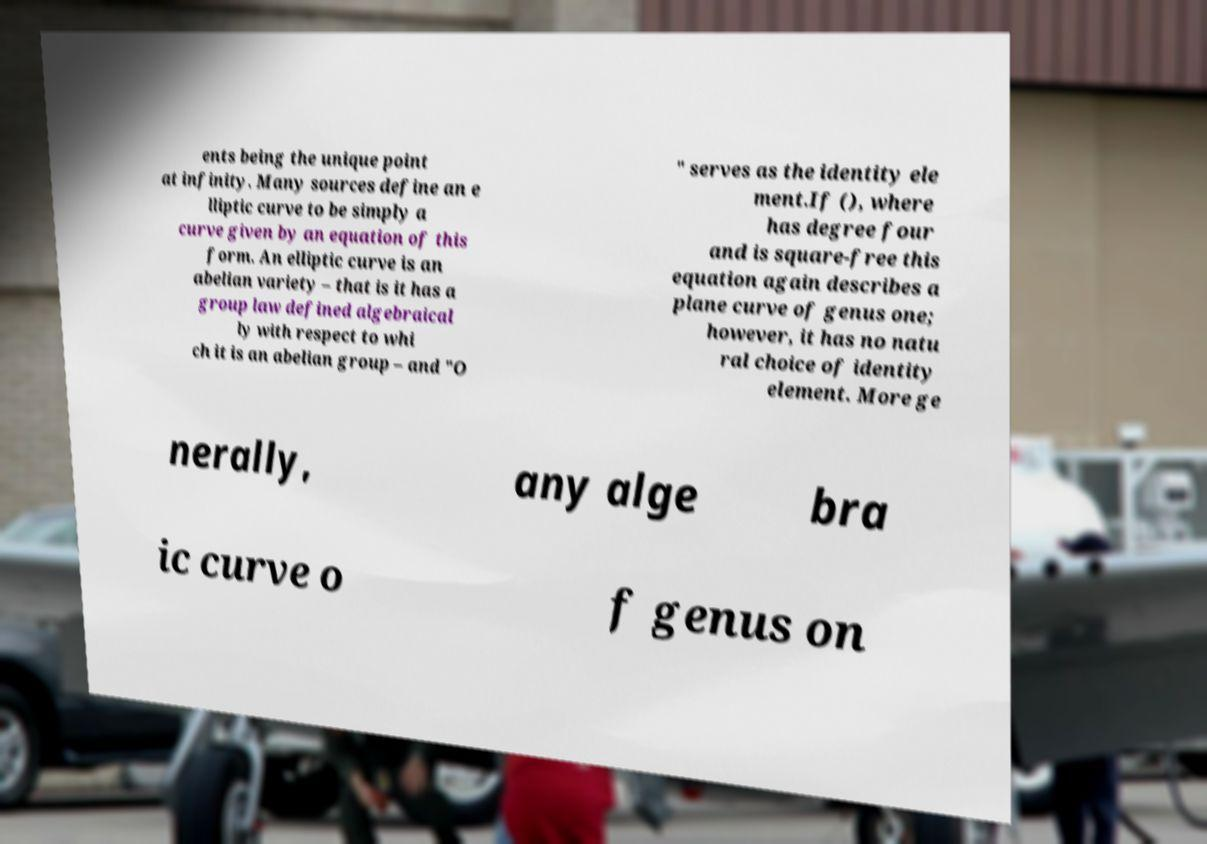Can you read and provide the text displayed in the image?This photo seems to have some interesting text. Can you extract and type it out for me? ents being the unique point at infinity. Many sources define an e lliptic curve to be simply a curve given by an equation of this form. An elliptic curve is an abelian variety – that is it has a group law defined algebraical ly with respect to whi ch it is an abelian group – and "O " serves as the identity ele ment.If (), where has degree four and is square-free this equation again describes a plane curve of genus one; however, it has no natu ral choice of identity element. More ge nerally, any alge bra ic curve o f genus on 